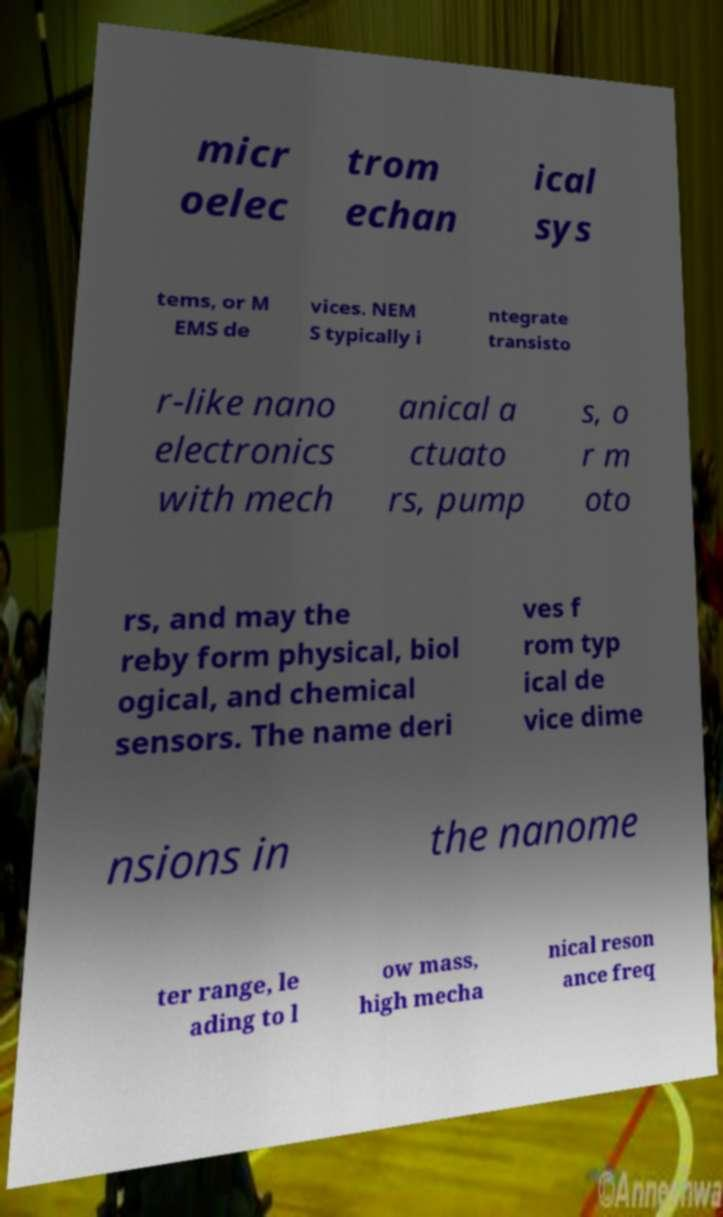Can you accurately transcribe the text from the provided image for me? micr oelec trom echan ical sys tems, or M EMS de vices. NEM S typically i ntegrate transisto r-like nano electronics with mech anical a ctuato rs, pump s, o r m oto rs, and may the reby form physical, biol ogical, and chemical sensors. The name deri ves f rom typ ical de vice dime nsions in the nanome ter range, le ading to l ow mass, high mecha nical reson ance freq 